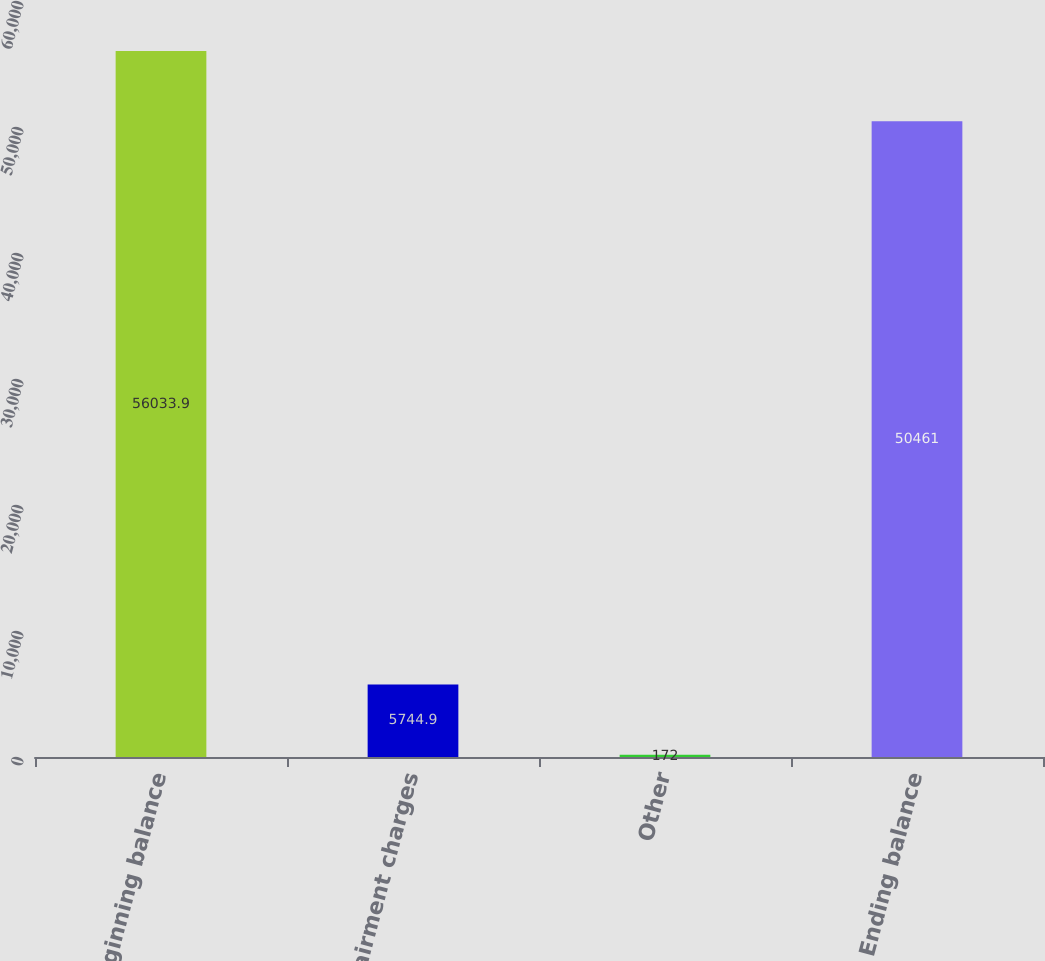Convert chart. <chart><loc_0><loc_0><loc_500><loc_500><bar_chart><fcel>Beginning balance<fcel>Impairment charges<fcel>Other<fcel>Ending balance<nl><fcel>56033.9<fcel>5744.9<fcel>172<fcel>50461<nl></chart> 